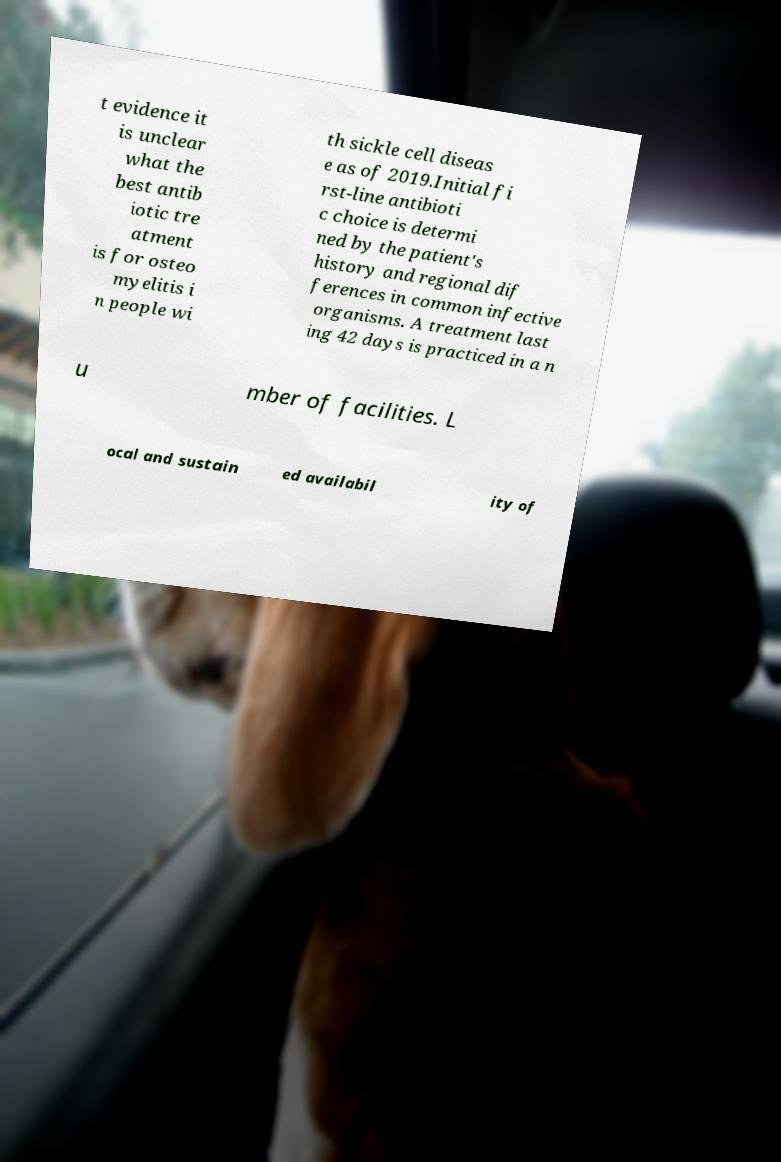What messages or text are displayed in this image? I need them in a readable, typed format. t evidence it is unclear what the best antib iotic tre atment is for osteo myelitis i n people wi th sickle cell diseas e as of 2019.Initial fi rst-line antibioti c choice is determi ned by the patient's history and regional dif ferences in common infective organisms. A treatment last ing 42 days is practiced in a n u mber of facilities. L ocal and sustain ed availabil ity of 